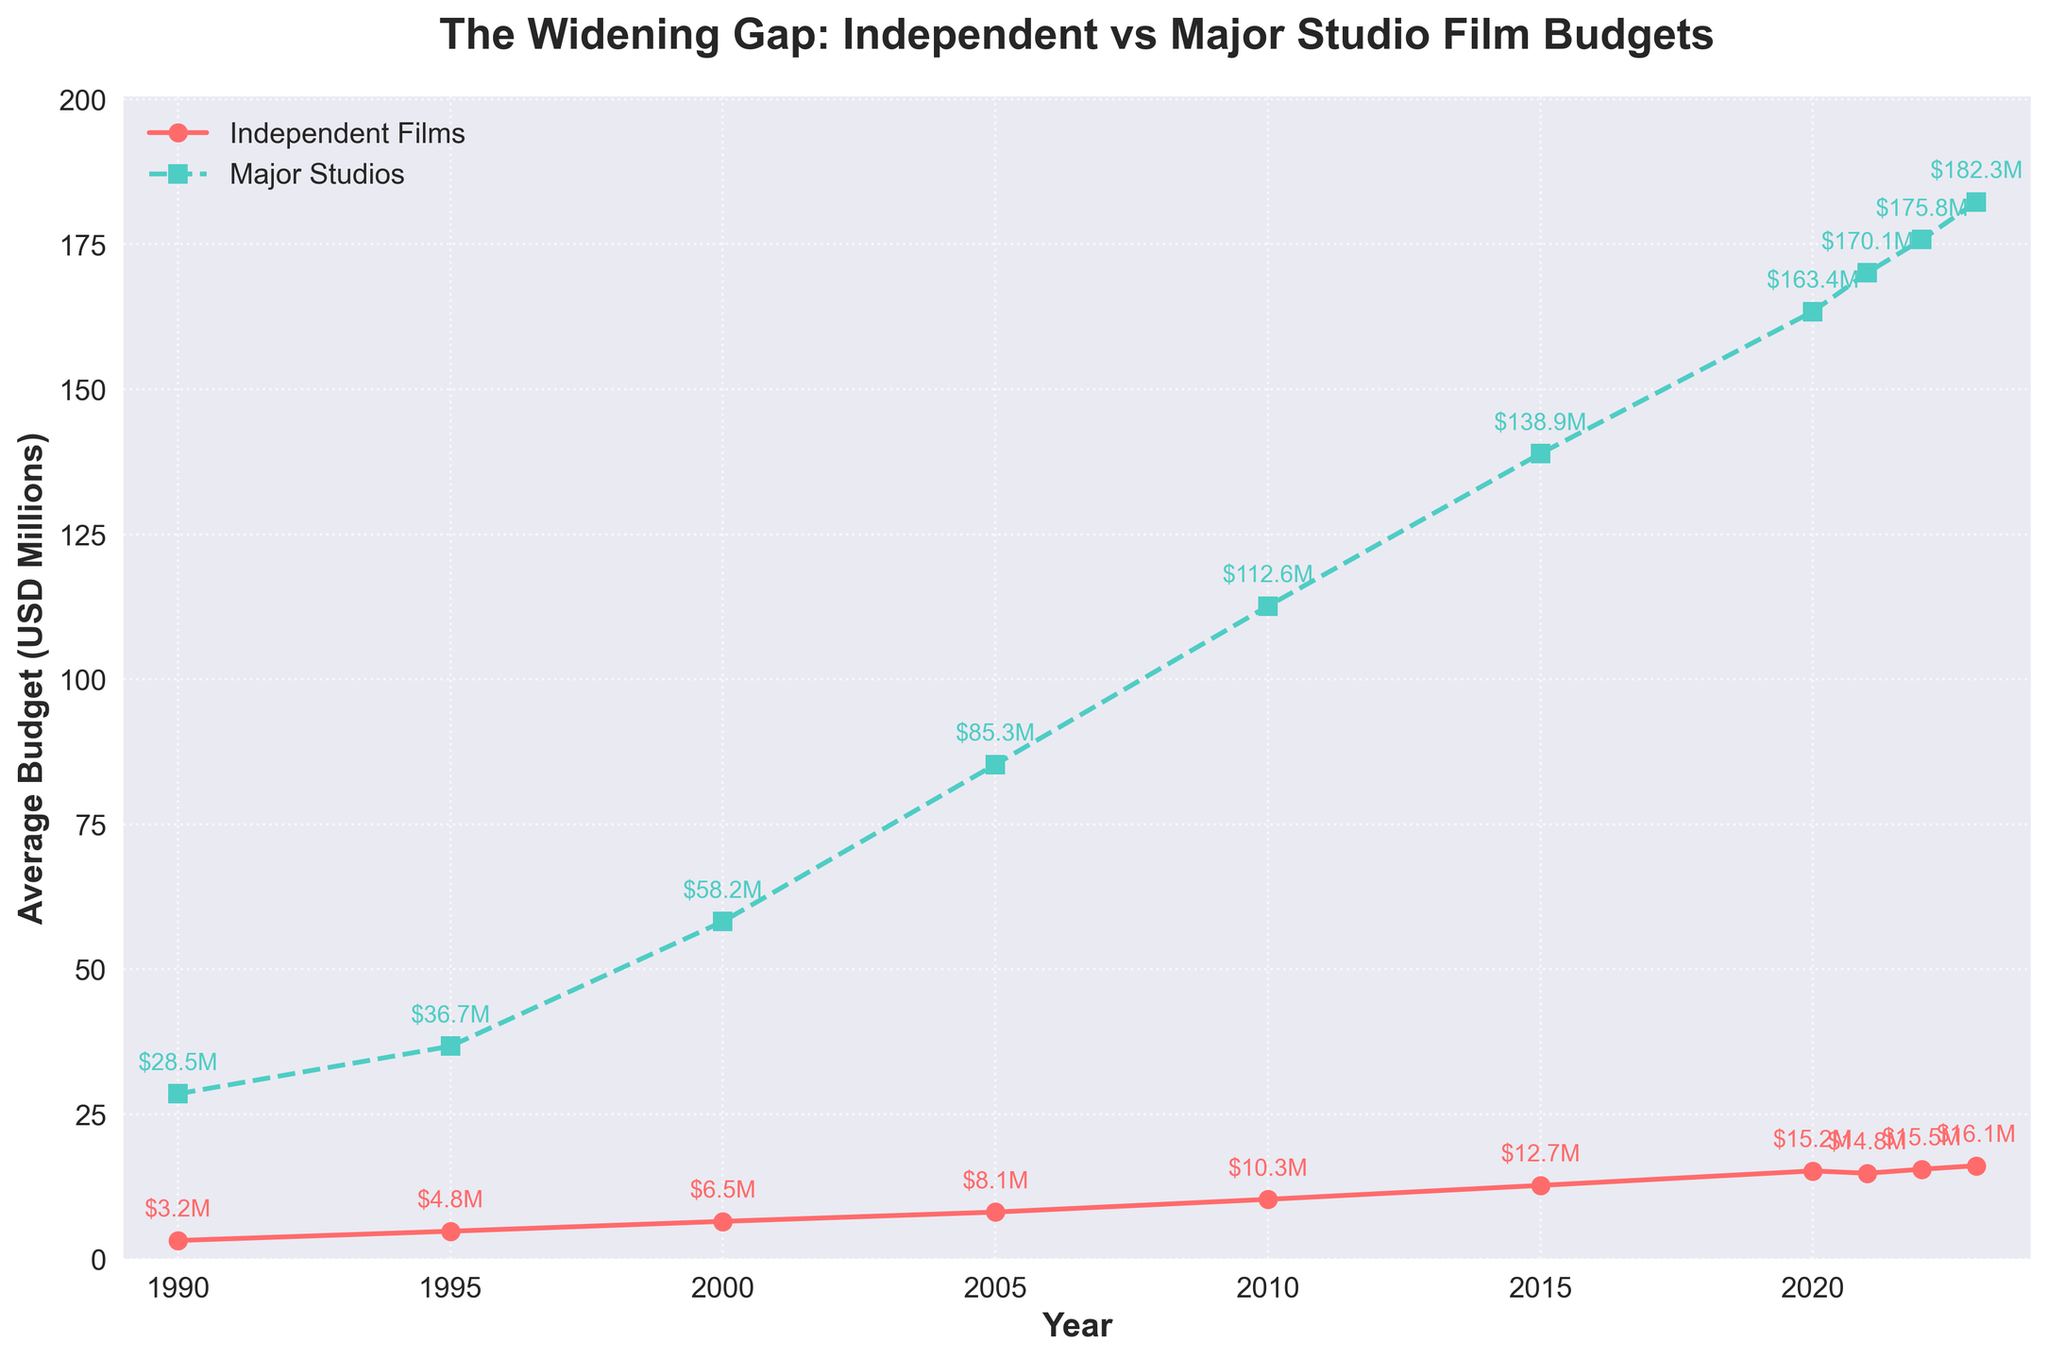What is the average budget of independent films in 2005? The independent films budget in 2005 can be found by looking at the red line at the year 2005. The marker shows a budget of $8.1M.
Answer: $8.1M What was the difference in average budgets between major studio productions and independent films in 2000? To find the difference in budgets, locate the values at the year 2000. The major studio productions have a budget of $58.2M and independent films have a budget of $6.5M. Subtract the independent films' budget from the major studio productions' budget: $58.2M - $6.5M = $51.7M.
Answer: $51.7M Which year had the largest budget difference between independent films and major studio productions? To identify the year with the largest difference, compare the gaps between the two lines for all years. The largest difference appears to be in 2023 where independent films average $16.1M and major studios average $182.3M, resulting in a difference of $166.2M.
Answer: 2023 How did the average budget of independent films change from 2010 to 2020? Look at the independent films' budget values for 2010 and 2020. The budget in 2010 was $10.3M and in 2020 it was $15.2M. The change is calculated by subtracting the 2010 budget from the 2020 budget: $15.2M - $10.3M = $4.9M.
Answer: Increased by $4.9M Are the average budgets of major studio productions in 2022 greater than in 2021? Compare the value for major studio productions in 2021 and 2022. In 2021, it was $170.1M, and in 2022, it was $175.8M. Since $175.8M is greater than $170.1M, the budgets are indeed greater.
Answer: Yes Which segment (independent films or major studio productions) saw a steady increase in budget every year from 1990 to 2023? To determine this, observe the trend lines for both segments. The red line (independent films) shows a steady increase every year while the green line (major studio productions) increases every year but starts to level off slightly around 2022-2023.
Answer: Independent films In which year did the average budget of independent films first exceed $10M? Find the value for independent films where it first surpasses $10M by following the red line. This first happens in 2010, where the value is $10.3M.
Answer: 2010 How much did the average budget of major studio productions increase from 1995 to 2023? Identify the values for major studio productions in 1995 and 2023. The budget in 1995 was $36.7M and in 2023 it is $182.3M. The increase is $182.3M - $36.7M = $145.6M.
Answer: $145.6M What's the trend in the budget gap between independent films and major studio productions over the years? The budget gap can be observed by looking at the vertical distance between the red and green lines through the years. The gap widens consistently from 1990 to present, indicating an increasing trend.
Answer: Increasing What is the visual difference between the markers used for independent films and major studio productions? By observing the lines, the independent films are marked with circles and a solid line (red), while the major studio productions are marked with squares and a dashed line (green).
Answer: Circles and solid line for independent films, squares and dashed line for major studio productions 